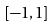<formula> <loc_0><loc_0><loc_500><loc_500>[ - 1 , 1 ]</formula> 